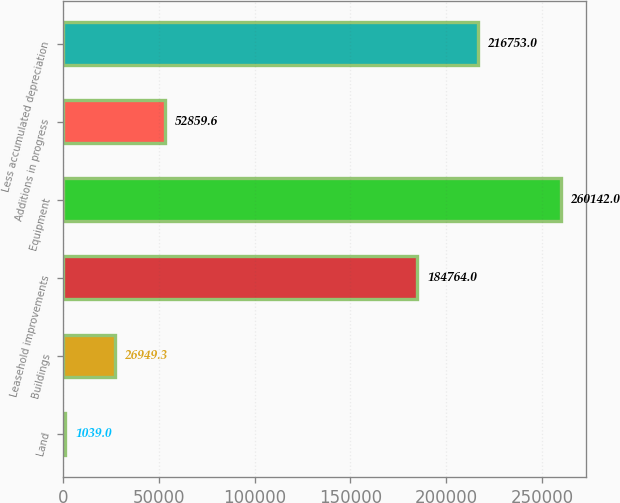<chart> <loc_0><loc_0><loc_500><loc_500><bar_chart><fcel>Land<fcel>Buildings<fcel>Leasehold improvements<fcel>Equipment<fcel>Additions in progress<fcel>Less accumulated depreciation<nl><fcel>1039<fcel>26949.3<fcel>184764<fcel>260142<fcel>52859.6<fcel>216753<nl></chart> 